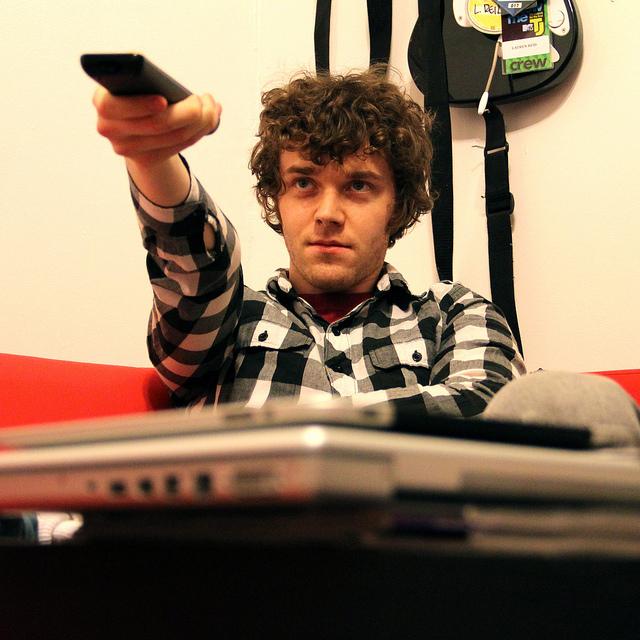Is the boy happy?
Short answer required. Yes. What type of pattern is on the man's shirt?
Give a very brief answer. Checkered. With what hand is he holding the controller?
Keep it brief. Right. 